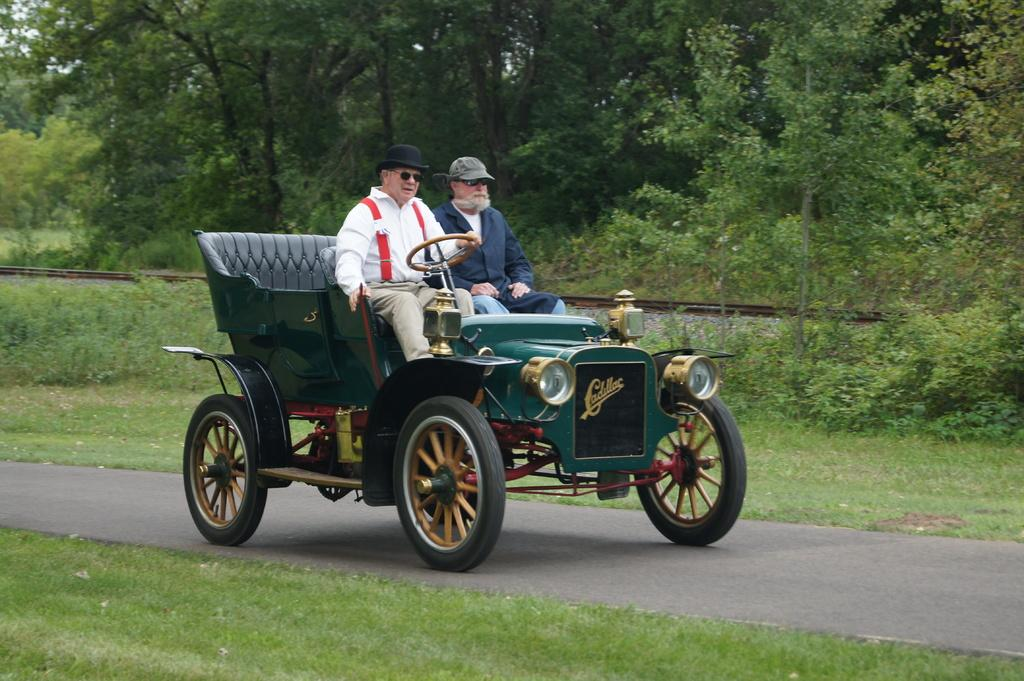How many men are present in the image? There are two men in the image. What are the two men doing in the image? The two men are moving in a car. Where is the car located in the image? The car is on the road. What can be seen in the background of the image? There are trees visible in the image. What type of lunch is the girl eating in the image? There is no girl present in the image, and therefore no such lunch-eating activity can be observed. 